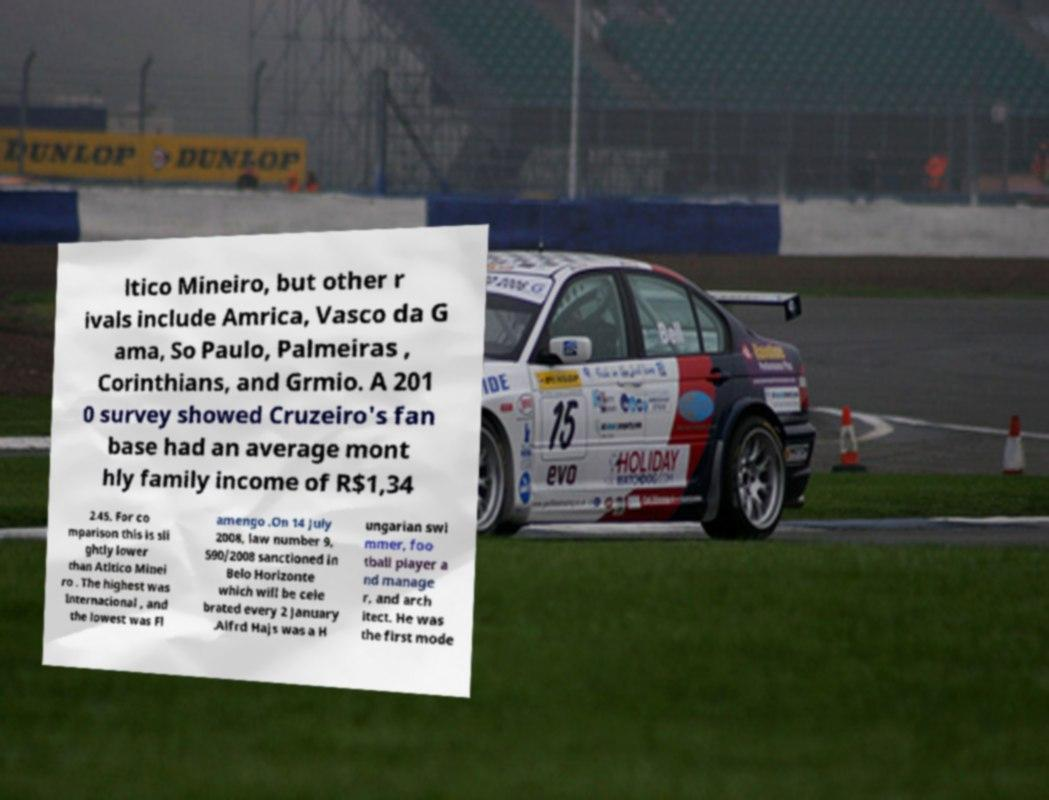What messages or text are displayed in this image? I need them in a readable, typed format. ltico Mineiro, but other r ivals include Amrica, Vasco da G ama, So Paulo, Palmeiras , Corinthians, and Grmio. A 201 0 survey showed Cruzeiro's fan base had an average mont hly family income of R$1,34 2.45. For co mparison this is sli ghtly lower than Atltico Minei ro . The highest was Internacional , and the lowest was Fl amengo .On 14 July 2008, law number 9, 590/2008 sanctioned in Belo Horizonte which will be cele brated every 2 January .Alfrd Hajs was a H ungarian swi mmer, foo tball player a nd manage r, and arch itect. He was the first mode 